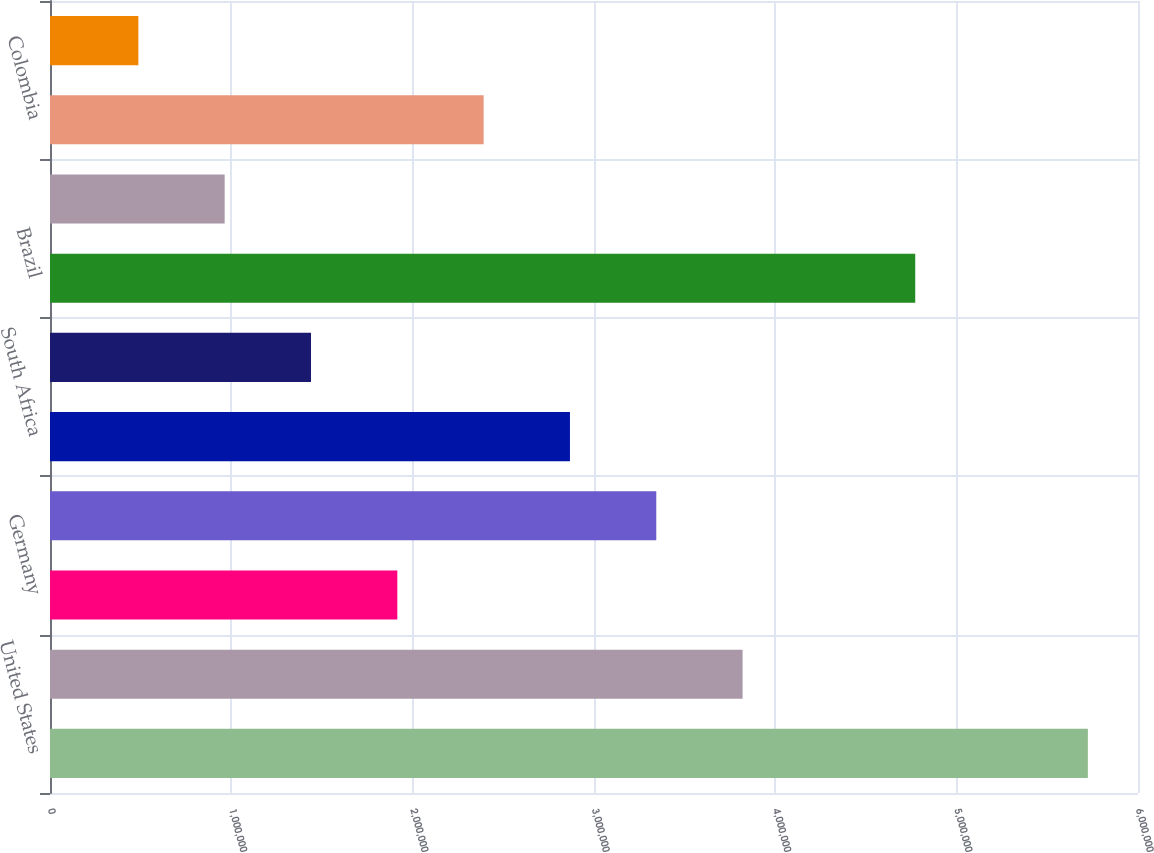Convert chart to OTSL. <chart><loc_0><loc_0><loc_500><loc_500><bar_chart><fcel>United States<fcel>India<fcel>Germany<fcel>Ghana<fcel>South Africa<fcel>Uganda<fcel>Brazil<fcel>Chile<fcel>Colombia<fcel>Costa Rica<nl><fcel>5.72357e+06<fcel>3.81946e+06<fcel>1.91534e+06<fcel>3.34343e+06<fcel>2.8674e+06<fcel>1.43931e+06<fcel>4.77152e+06<fcel>963281<fcel>2.39137e+06<fcel>487251<nl></chart> 